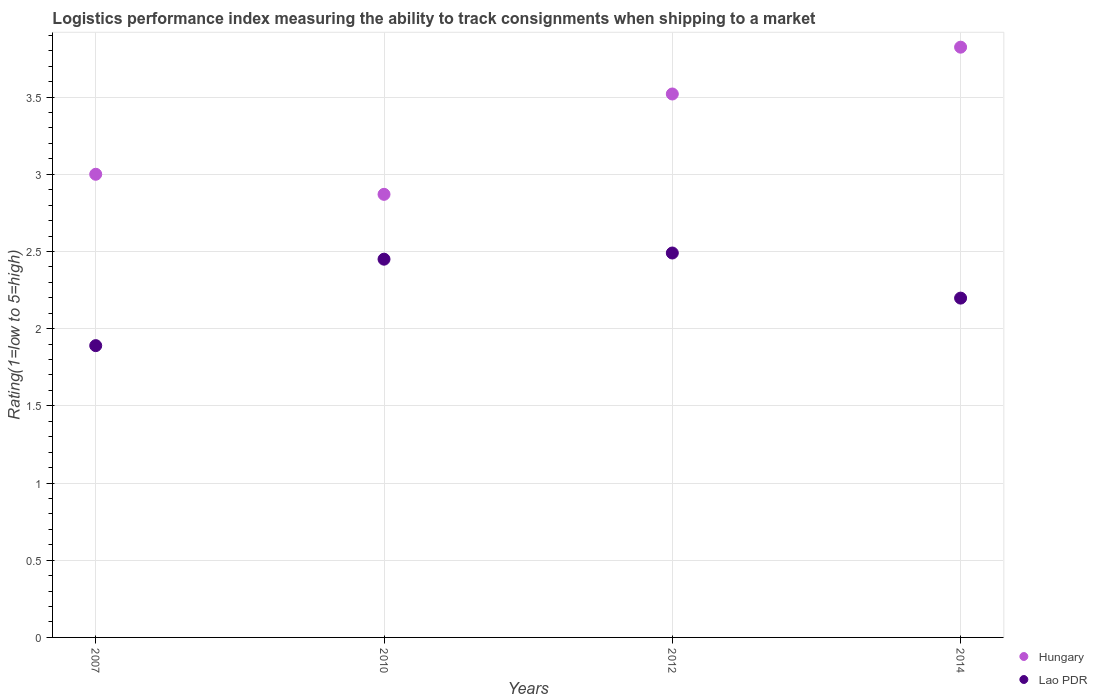Is the number of dotlines equal to the number of legend labels?
Keep it short and to the point. Yes. What is the Logistic performance index in Hungary in 2010?
Provide a succinct answer. 2.87. Across all years, what is the maximum Logistic performance index in Hungary?
Provide a succinct answer. 3.82. Across all years, what is the minimum Logistic performance index in Hungary?
Keep it short and to the point. 2.87. What is the total Logistic performance index in Lao PDR in the graph?
Ensure brevity in your answer.  9.03. What is the difference between the Logistic performance index in Lao PDR in 2010 and that in 2012?
Give a very brief answer. -0.04. What is the difference between the Logistic performance index in Lao PDR in 2007 and the Logistic performance index in Hungary in 2012?
Your answer should be very brief. -1.63. What is the average Logistic performance index in Hungary per year?
Give a very brief answer. 3.3. In the year 2014, what is the difference between the Logistic performance index in Hungary and Logistic performance index in Lao PDR?
Offer a very short reply. 1.63. In how many years, is the Logistic performance index in Lao PDR greater than 2.8?
Provide a succinct answer. 0. What is the ratio of the Logistic performance index in Hungary in 2007 to that in 2012?
Provide a succinct answer. 0.85. Is the difference between the Logistic performance index in Hungary in 2007 and 2010 greater than the difference between the Logistic performance index in Lao PDR in 2007 and 2010?
Your response must be concise. Yes. What is the difference between the highest and the second highest Logistic performance index in Lao PDR?
Ensure brevity in your answer.  0.04. What is the difference between the highest and the lowest Logistic performance index in Lao PDR?
Your answer should be compact. 0.6. In how many years, is the Logistic performance index in Hungary greater than the average Logistic performance index in Hungary taken over all years?
Your answer should be very brief. 2. Is the sum of the Logistic performance index in Hungary in 2007 and 2014 greater than the maximum Logistic performance index in Lao PDR across all years?
Provide a short and direct response. Yes. Does the Logistic performance index in Lao PDR monotonically increase over the years?
Keep it short and to the point. No. Is the Logistic performance index in Lao PDR strictly less than the Logistic performance index in Hungary over the years?
Offer a very short reply. Yes. How many dotlines are there?
Provide a succinct answer. 2. What is the difference between two consecutive major ticks on the Y-axis?
Offer a terse response. 0.5. Are the values on the major ticks of Y-axis written in scientific E-notation?
Provide a succinct answer. No. Does the graph contain grids?
Your response must be concise. Yes. Where does the legend appear in the graph?
Provide a succinct answer. Bottom right. How many legend labels are there?
Ensure brevity in your answer.  2. What is the title of the graph?
Keep it short and to the point. Logistics performance index measuring the ability to track consignments when shipping to a market. Does "Macedonia" appear as one of the legend labels in the graph?
Provide a short and direct response. No. What is the label or title of the Y-axis?
Offer a very short reply. Rating(1=low to 5=high). What is the Rating(1=low to 5=high) in Lao PDR in 2007?
Provide a short and direct response. 1.89. What is the Rating(1=low to 5=high) of Hungary in 2010?
Provide a short and direct response. 2.87. What is the Rating(1=low to 5=high) in Lao PDR in 2010?
Provide a short and direct response. 2.45. What is the Rating(1=low to 5=high) of Hungary in 2012?
Keep it short and to the point. 3.52. What is the Rating(1=low to 5=high) in Lao PDR in 2012?
Make the answer very short. 2.49. What is the Rating(1=low to 5=high) of Hungary in 2014?
Your answer should be very brief. 3.82. What is the Rating(1=low to 5=high) in Lao PDR in 2014?
Your answer should be compact. 2.2. Across all years, what is the maximum Rating(1=low to 5=high) of Hungary?
Ensure brevity in your answer.  3.82. Across all years, what is the maximum Rating(1=low to 5=high) of Lao PDR?
Give a very brief answer. 2.49. Across all years, what is the minimum Rating(1=low to 5=high) of Hungary?
Your answer should be very brief. 2.87. Across all years, what is the minimum Rating(1=low to 5=high) of Lao PDR?
Your response must be concise. 1.89. What is the total Rating(1=low to 5=high) of Hungary in the graph?
Your answer should be compact. 13.21. What is the total Rating(1=low to 5=high) of Lao PDR in the graph?
Ensure brevity in your answer.  9.03. What is the difference between the Rating(1=low to 5=high) in Hungary in 2007 and that in 2010?
Provide a short and direct response. 0.13. What is the difference between the Rating(1=low to 5=high) of Lao PDR in 2007 and that in 2010?
Make the answer very short. -0.56. What is the difference between the Rating(1=low to 5=high) in Hungary in 2007 and that in 2012?
Provide a succinct answer. -0.52. What is the difference between the Rating(1=low to 5=high) in Lao PDR in 2007 and that in 2012?
Your answer should be compact. -0.6. What is the difference between the Rating(1=low to 5=high) in Hungary in 2007 and that in 2014?
Your response must be concise. -0.82. What is the difference between the Rating(1=low to 5=high) in Lao PDR in 2007 and that in 2014?
Provide a succinct answer. -0.31. What is the difference between the Rating(1=low to 5=high) in Hungary in 2010 and that in 2012?
Offer a terse response. -0.65. What is the difference between the Rating(1=low to 5=high) in Lao PDR in 2010 and that in 2012?
Keep it short and to the point. -0.04. What is the difference between the Rating(1=low to 5=high) in Hungary in 2010 and that in 2014?
Provide a succinct answer. -0.95. What is the difference between the Rating(1=low to 5=high) in Lao PDR in 2010 and that in 2014?
Provide a succinct answer. 0.25. What is the difference between the Rating(1=low to 5=high) in Hungary in 2012 and that in 2014?
Your response must be concise. -0.3. What is the difference between the Rating(1=low to 5=high) in Lao PDR in 2012 and that in 2014?
Give a very brief answer. 0.29. What is the difference between the Rating(1=low to 5=high) in Hungary in 2007 and the Rating(1=low to 5=high) in Lao PDR in 2010?
Give a very brief answer. 0.55. What is the difference between the Rating(1=low to 5=high) of Hungary in 2007 and the Rating(1=low to 5=high) of Lao PDR in 2012?
Ensure brevity in your answer.  0.51. What is the difference between the Rating(1=low to 5=high) in Hungary in 2007 and the Rating(1=low to 5=high) in Lao PDR in 2014?
Your answer should be compact. 0.8. What is the difference between the Rating(1=low to 5=high) in Hungary in 2010 and the Rating(1=low to 5=high) in Lao PDR in 2012?
Make the answer very short. 0.38. What is the difference between the Rating(1=low to 5=high) in Hungary in 2010 and the Rating(1=low to 5=high) in Lao PDR in 2014?
Keep it short and to the point. 0.67. What is the difference between the Rating(1=low to 5=high) in Hungary in 2012 and the Rating(1=low to 5=high) in Lao PDR in 2014?
Ensure brevity in your answer.  1.32. What is the average Rating(1=low to 5=high) of Hungary per year?
Ensure brevity in your answer.  3.3. What is the average Rating(1=low to 5=high) in Lao PDR per year?
Make the answer very short. 2.26. In the year 2007, what is the difference between the Rating(1=low to 5=high) of Hungary and Rating(1=low to 5=high) of Lao PDR?
Provide a succinct answer. 1.11. In the year 2010, what is the difference between the Rating(1=low to 5=high) of Hungary and Rating(1=low to 5=high) of Lao PDR?
Your answer should be compact. 0.42. In the year 2014, what is the difference between the Rating(1=low to 5=high) of Hungary and Rating(1=low to 5=high) of Lao PDR?
Offer a very short reply. 1.63. What is the ratio of the Rating(1=low to 5=high) of Hungary in 2007 to that in 2010?
Offer a terse response. 1.05. What is the ratio of the Rating(1=low to 5=high) of Lao PDR in 2007 to that in 2010?
Your response must be concise. 0.77. What is the ratio of the Rating(1=low to 5=high) in Hungary in 2007 to that in 2012?
Your response must be concise. 0.85. What is the ratio of the Rating(1=low to 5=high) in Lao PDR in 2007 to that in 2012?
Give a very brief answer. 0.76. What is the ratio of the Rating(1=low to 5=high) in Hungary in 2007 to that in 2014?
Ensure brevity in your answer.  0.78. What is the ratio of the Rating(1=low to 5=high) of Lao PDR in 2007 to that in 2014?
Keep it short and to the point. 0.86. What is the ratio of the Rating(1=low to 5=high) of Hungary in 2010 to that in 2012?
Your answer should be very brief. 0.82. What is the ratio of the Rating(1=low to 5=high) of Lao PDR in 2010 to that in 2012?
Your response must be concise. 0.98. What is the ratio of the Rating(1=low to 5=high) in Hungary in 2010 to that in 2014?
Offer a terse response. 0.75. What is the ratio of the Rating(1=low to 5=high) of Lao PDR in 2010 to that in 2014?
Your response must be concise. 1.11. What is the ratio of the Rating(1=low to 5=high) in Hungary in 2012 to that in 2014?
Provide a short and direct response. 0.92. What is the ratio of the Rating(1=low to 5=high) in Lao PDR in 2012 to that in 2014?
Provide a succinct answer. 1.13. What is the difference between the highest and the second highest Rating(1=low to 5=high) of Hungary?
Keep it short and to the point. 0.3. What is the difference between the highest and the lowest Rating(1=low to 5=high) of Hungary?
Your response must be concise. 0.95. 